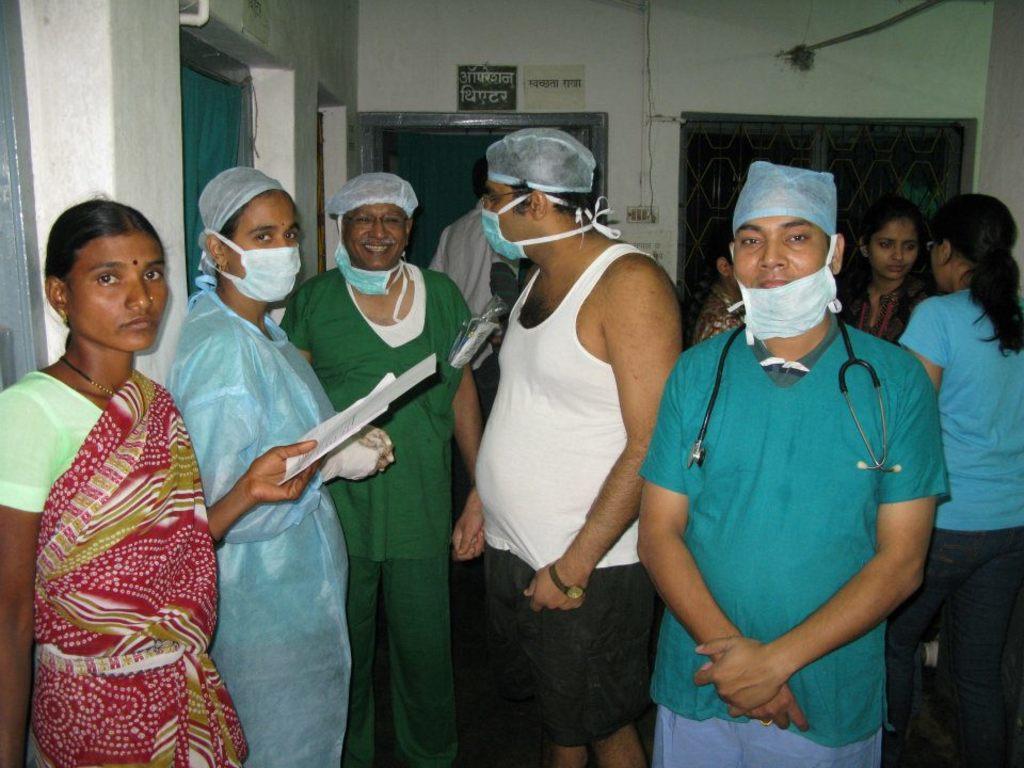In one or two sentences, can you explain what this image depicts? In the image we can see there are people standing and they are wearing head cap and mask on their nose and mouth. There is a man wearing stethoscope around his neck and there is a woman holding papers in her hand. Behind there is a paper pasted on the wall. 